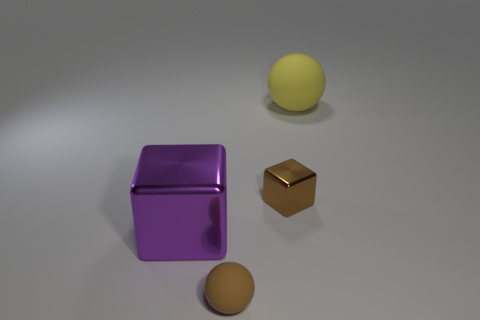Add 4 big blocks. How many objects exist? 8 Add 4 tiny brown objects. How many tiny brown objects are left? 6 Add 3 metallic blocks. How many metallic blocks exist? 5 Subtract all brown balls. How many balls are left? 1 Subtract 0 blue balls. How many objects are left? 4 Subtract all gray blocks. Subtract all brown spheres. How many blocks are left? 2 Subtract all red spheres. How many brown cubes are left? 1 Subtract all large yellow rubber objects. Subtract all large purple metallic cubes. How many objects are left? 2 